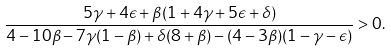Convert formula to latex. <formula><loc_0><loc_0><loc_500><loc_500>\frac { 5 \gamma + 4 \epsilon + \beta ( 1 + 4 \gamma + 5 \epsilon + \delta ) } { 4 - 1 0 \beta - 7 \gamma ( 1 - \beta ) + \delta ( 8 + \beta ) - ( 4 - 3 \beta ) ( 1 - \gamma - \epsilon ) } > 0 .</formula> 